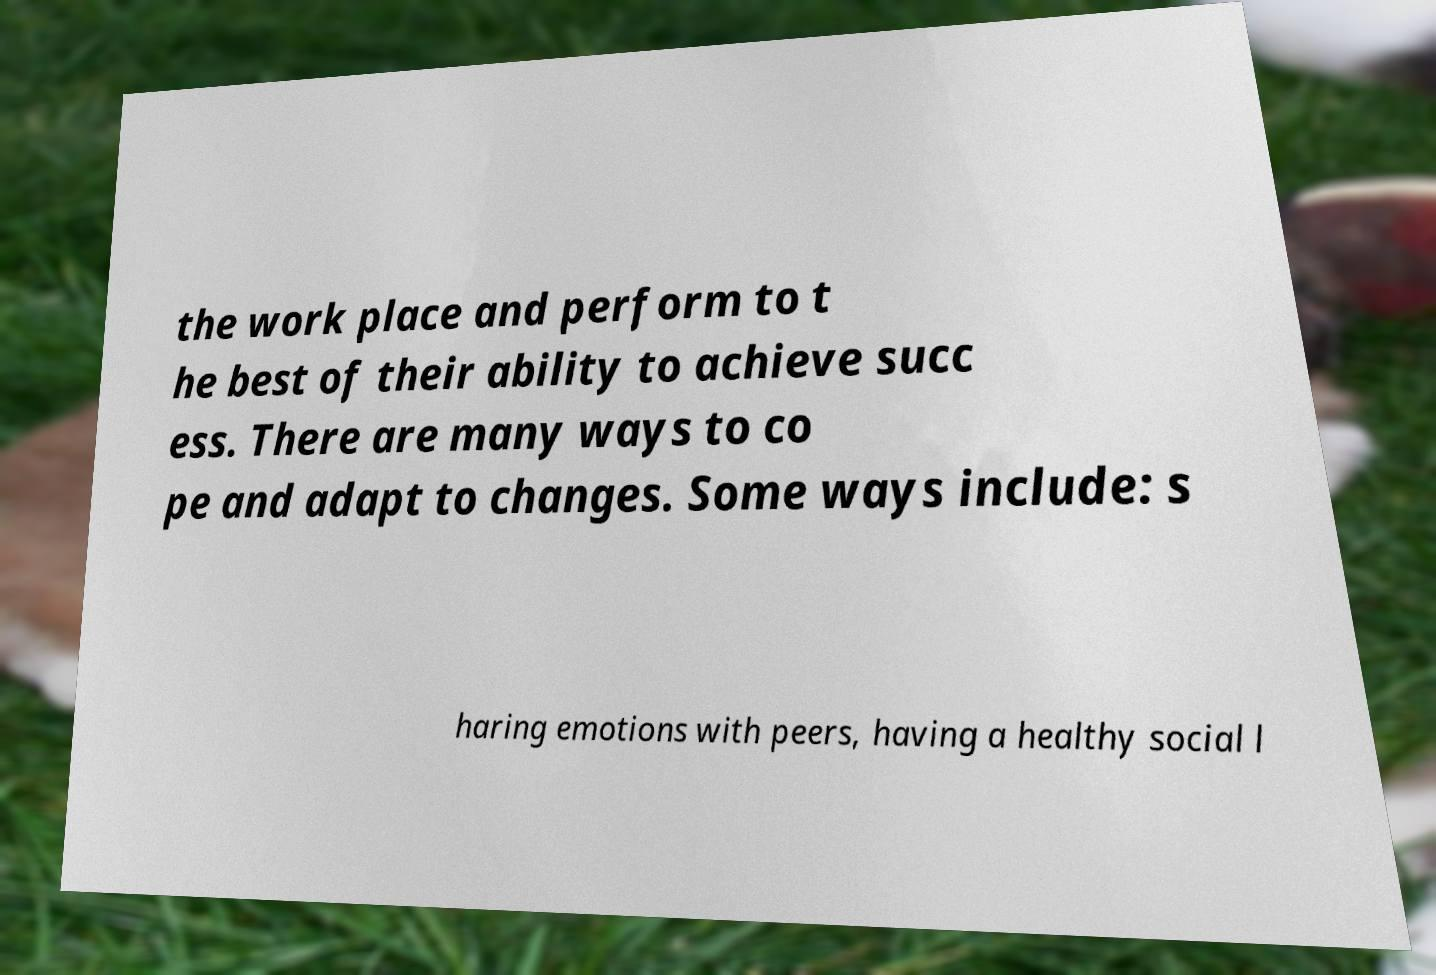Could you extract and type out the text from this image? the work place and perform to t he best of their ability to achieve succ ess. There are many ways to co pe and adapt to changes. Some ways include: s haring emotions with peers, having a healthy social l 